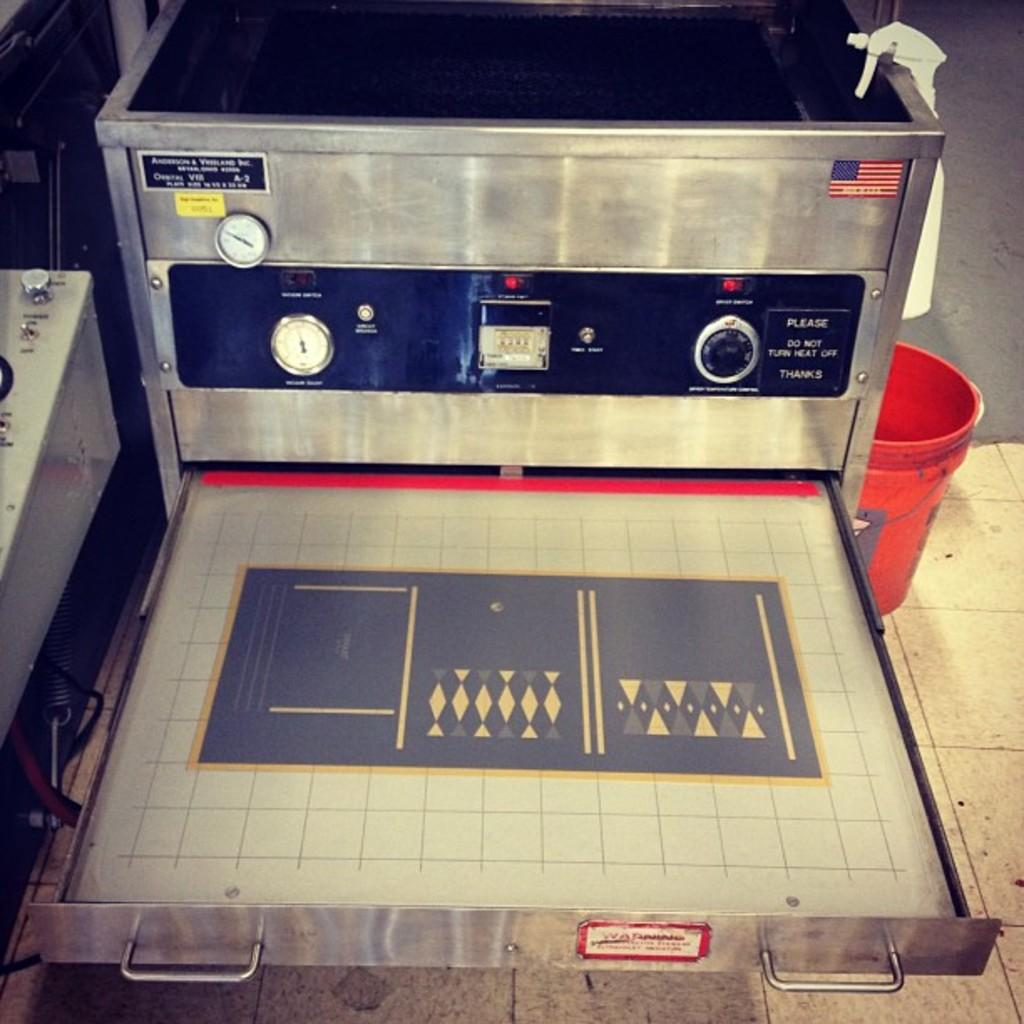Provide a one-sentence caption for the provided image. A machine that has a sticker reading please do not turn heat off. 